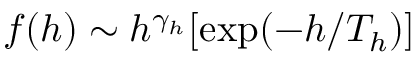<formula> <loc_0><loc_0><loc_500><loc_500>f ( h ) \sim h ^ { \gamma _ { h } } [ e x p ( - h / T _ { h } ) ]</formula> 